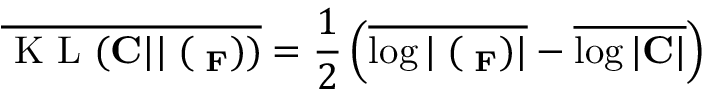<formula> <loc_0><loc_0><loc_500><loc_500>\overline { { K L ( { C } | | { \Xi } ( { \Lambda _ { F } } ) ) } } = \frac { 1 } { 2 } \left ( \overline { { \log | { \Xi } ( { \Lambda _ { F } } ) | } } - \overline { { \log | { C } | } } \right )</formula> 